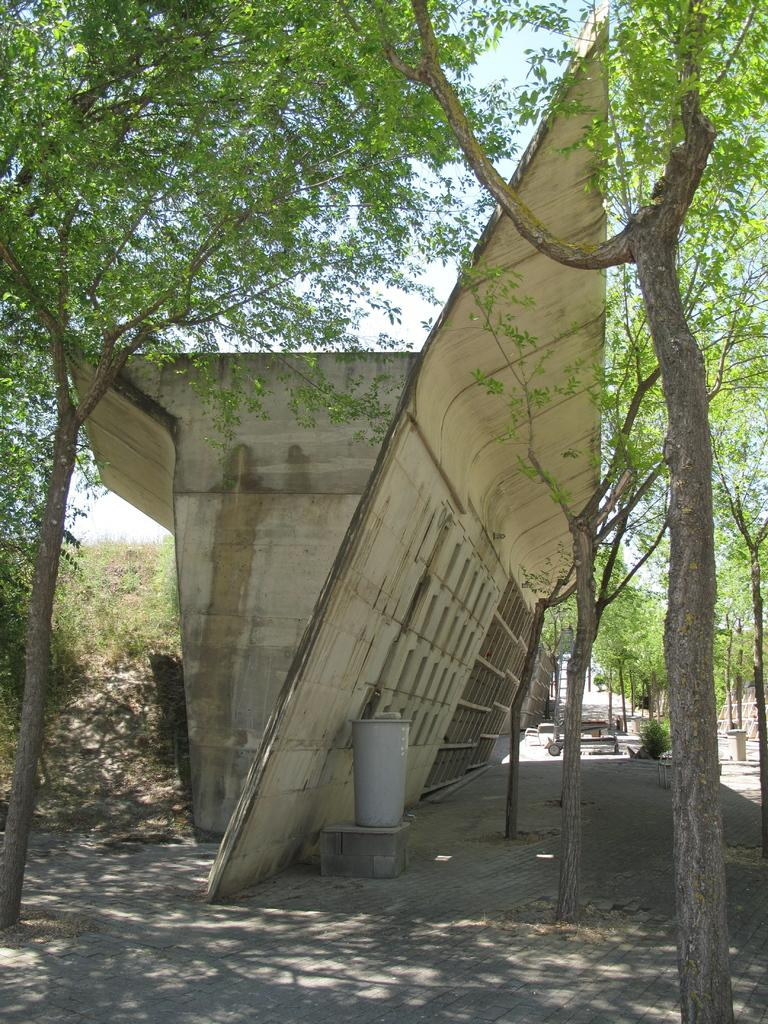What type of structure is in the image? There is a construction bridge in the image. What objects can be seen at the bottom of the image? There are dustbins at the bottom of the image. What type of vegetation is visible in the background of the image? There are trees, plants, and grass in the background of the image. What is visible at the top of the image? The sky is visible at the top of the image. What can be seen in the sky? Clouds are present in the sky. What type of gold blade can be seen in the image? There is no gold blade present in the image. 